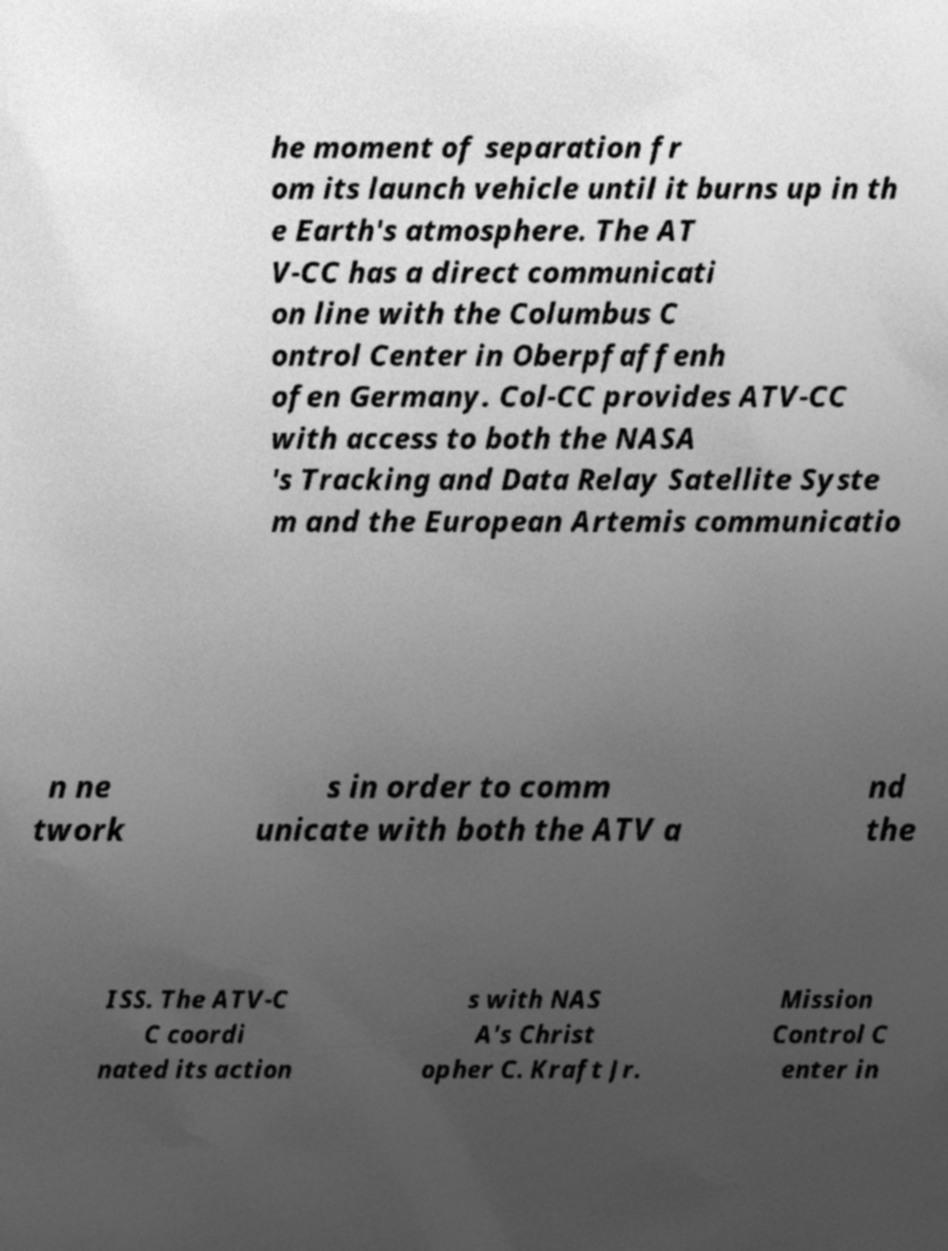Can you accurately transcribe the text from the provided image for me? he moment of separation fr om its launch vehicle until it burns up in th e Earth's atmosphere. The AT V-CC has a direct communicati on line with the Columbus C ontrol Center in Oberpfaffenh ofen Germany. Col-CC provides ATV-CC with access to both the NASA 's Tracking and Data Relay Satellite Syste m and the European Artemis communicatio n ne twork s in order to comm unicate with both the ATV a nd the ISS. The ATV-C C coordi nated its action s with NAS A's Christ opher C. Kraft Jr. Mission Control C enter in 